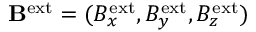<formula> <loc_0><loc_0><loc_500><loc_500>B ^ { e x t } = ( B _ { x } ^ { e x t } , B _ { y } ^ { e x t } , B _ { z } ^ { e x t } )</formula> 